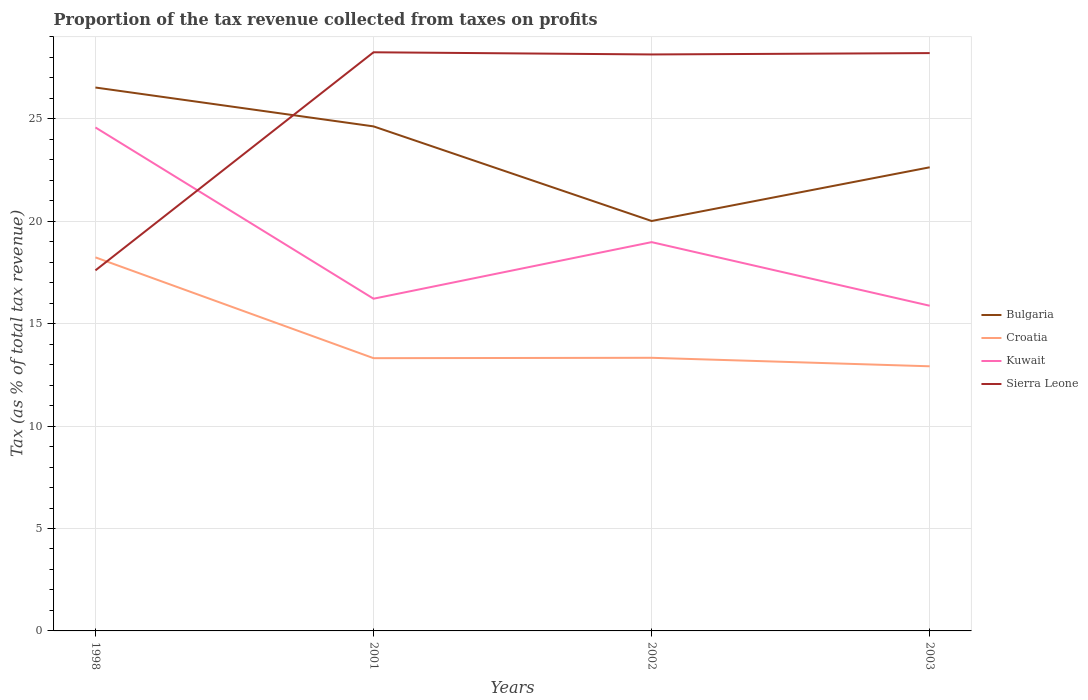How many different coloured lines are there?
Make the answer very short. 4. Is the number of lines equal to the number of legend labels?
Give a very brief answer. Yes. Across all years, what is the maximum proportion of the tax revenue collected in Bulgaria?
Your answer should be compact. 20.01. What is the total proportion of the tax revenue collected in Kuwait in the graph?
Your response must be concise. 0.34. What is the difference between the highest and the second highest proportion of the tax revenue collected in Sierra Leone?
Your response must be concise. 10.65. How many years are there in the graph?
Your answer should be compact. 4. Does the graph contain any zero values?
Give a very brief answer. No. Where does the legend appear in the graph?
Offer a very short reply. Center right. How are the legend labels stacked?
Give a very brief answer. Vertical. What is the title of the graph?
Offer a very short reply. Proportion of the tax revenue collected from taxes on profits. What is the label or title of the Y-axis?
Ensure brevity in your answer.  Tax (as % of total tax revenue). What is the Tax (as % of total tax revenue) of Bulgaria in 1998?
Give a very brief answer. 26.53. What is the Tax (as % of total tax revenue) of Croatia in 1998?
Keep it short and to the point. 18.23. What is the Tax (as % of total tax revenue) in Kuwait in 1998?
Your response must be concise. 24.58. What is the Tax (as % of total tax revenue) of Sierra Leone in 1998?
Offer a very short reply. 17.6. What is the Tax (as % of total tax revenue) in Bulgaria in 2001?
Keep it short and to the point. 24.63. What is the Tax (as % of total tax revenue) of Croatia in 2001?
Offer a very short reply. 13.31. What is the Tax (as % of total tax revenue) in Kuwait in 2001?
Provide a short and direct response. 16.22. What is the Tax (as % of total tax revenue) of Sierra Leone in 2001?
Make the answer very short. 28.25. What is the Tax (as % of total tax revenue) in Bulgaria in 2002?
Offer a terse response. 20.01. What is the Tax (as % of total tax revenue) in Croatia in 2002?
Provide a short and direct response. 13.33. What is the Tax (as % of total tax revenue) of Kuwait in 2002?
Provide a succinct answer. 18.98. What is the Tax (as % of total tax revenue) of Sierra Leone in 2002?
Provide a short and direct response. 28.14. What is the Tax (as % of total tax revenue) in Bulgaria in 2003?
Provide a short and direct response. 22.63. What is the Tax (as % of total tax revenue) in Croatia in 2003?
Offer a terse response. 12.92. What is the Tax (as % of total tax revenue) in Kuwait in 2003?
Offer a very short reply. 15.87. What is the Tax (as % of total tax revenue) of Sierra Leone in 2003?
Keep it short and to the point. 28.21. Across all years, what is the maximum Tax (as % of total tax revenue) of Bulgaria?
Keep it short and to the point. 26.53. Across all years, what is the maximum Tax (as % of total tax revenue) in Croatia?
Offer a terse response. 18.23. Across all years, what is the maximum Tax (as % of total tax revenue) of Kuwait?
Your answer should be very brief. 24.58. Across all years, what is the maximum Tax (as % of total tax revenue) in Sierra Leone?
Ensure brevity in your answer.  28.25. Across all years, what is the minimum Tax (as % of total tax revenue) in Bulgaria?
Offer a very short reply. 20.01. Across all years, what is the minimum Tax (as % of total tax revenue) in Croatia?
Ensure brevity in your answer.  12.92. Across all years, what is the minimum Tax (as % of total tax revenue) in Kuwait?
Offer a very short reply. 15.87. Across all years, what is the minimum Tax (as % of total tax revenue) of Sierra Leone?
Your response must be concise. 17.6. What is the total Tax (as % of total tax revenue) of Bulgaria in the graph?
Ensure brevity in your answer.  93.8. What is the total Tax (as % of total tax revenue) in Croatia in the graph?
Offer a terse response. 57.8. What is the total Tax (as % of total tax revenue) of Kuwait in the graph?
Your response must be concise. 75.64. What is the total Tax (as % of total tax revenue) in Sierra Leone in the graph?
Your answer should be very brief. 102.19. What is the difference between the Tax (as % of total tax revenue) of Bulgaria in 1998 and that in 2001?
Your answer should be very brief. 1.9. What is the difference between the Tax (as % of total tax revenue) of Croatia in 1998 and that in 2001?
Provide a short and direct response. 4.92. What is the difference between the Tax (as % of total tax revenue) of Kuwait in 1998 and that in 2001?
Your response must be concise. 8.36. What is the difference between the Tax (as % of total tax revenue) in Sierra Leone in 1998 and that in 2001?
Give a very brief answer. -10.65. What is the difference between the Tax (as % of total tax revenue) in Bulgaria in 1998 and that in 2002?
Your answer should be compact. 6.52. What is the difference between the Tax (as % of total tax revenue) in Croatia in 1998 and that in 2002?
Your response must be concise. 4.9. What is the difference between the Tax (as % of total tax revenue) in Kuwait in 1998 and that in 2002?
Provide a short and direct response. 5.6. What is the difference between the Tax (as % of total tax revenue) of Sierra Leone in 1998 and that in 2002?
Your answer should be very brief. -10.54. What is the difference between the Tax (as % of total tax revenue) of Bulgaria in 1998 and that in 2003?
Offer a terse response. 3.89. What is the difference between the Tax (as % of total tax revenue) in Croatia in 1998 and that in 2003?
Offer a terse response. 5.32. What is the difference between the Tax (as % of total tax revenue) of Kuwait in 1998 and that in 2003?
Your answer should be very brief. 8.7. What is the difference between the Tax (as % of total tax revenue) in Sierra Leone in 1998 and that in 2003?
Keep it short and to the point. -10.61. What is the difference between the Tax (as % of total tax revenue) in Bulgaria in 2001 and that in 2002?
Your response must be concise. 4.62. What is the difference between the Tax (as % of total tax revenue) of Croatia in 2001 and that in 2002?
Offer a terse response. -0.02. What is the difference between the Tax (as % of total tax revenue) in Kuwait in 2001 and that in 2002?
Offer a very short reply. -2.76. What is the difference between the Tax (as % of total tax revenue) in Sierra Leone in 2001 and that in 2002?
Provide a succinct answer. 0.11. What is the difference between the Tax (as % of total tax revenue) in Bulgaria in 2001 and that in 2003?
Your response must be concise. 2. What is the difference between the Tax (as % of total tax revenue) in Croatia in 2001 and that in 2003?
Your response must be concise. 0.4. What is the difference between the Tax (as % of total tax revenue) of Kuwait in 2001 and that in 2003?
Give a very brief answer. 0.34. What is the difference between the Tax (as % of total tax revenue) of Sierra Leone in 2001 and that in 2003?
Your answer should be compact. 0.04. What is the difference between the Tax (as % of total tax revenue) in Bulgaria in 2002 and that in 2003?
Your answer should be compact. -2.62. What is the difference between the Tax (as % of total tax revenue) in Croatia in 2002 and that in 2003?
Offer a terse response. 0.41. What is the difference between the Tax (as % of total tax revenue) in Kuwait in 2002 and that in 2003?
Provide a succinct answer. 3.11. What is the difference between the Tax (as % of total tax revenue) in Sierra Leone in 2002 and that in 2003?
Offer a terse response. -0.07. What is the difference between the Tax (as % of total tax revenue) of Bulgaria in 1998 and the Tax (as % of total tax revenue) of Croatia in 2001?
Offer a very short reply. 13.21. What is the difference between the Tax (as % of total tax revenue) in Bulgaria in 1998 and the Tax (as % of total tax revenue) in Kuwait in 2001?
Make the answer very short. 10.31. What is the difference between the Tax (as % of total tax revenue) in Bulgaria in 1998 and the Tax (as % of total tax revenue) in Sierra Leone in 2001?
Give a very brief answer. -1.72. What is the difference between the Tax (as % of total tax revenue) in Croatia in 1998 and the Tax (as % of total tax revenue) in Kuwait in 2001?
Provide a succinct answer. 2.02. What is the difference between the Tax (as % of total tax revenue) of Croatia in 1998 and the Tax (as % of total tax revenue) of Sierra Leone in 2001?
Your answer should be compact. -10.01. What is the difference between the Tax (as % of total tax revenue) in Kuwait in 1998 and the Tax (as % of total tax revenue) in Sierra Leone in 2001?
Provide a short and direct response. -3.67. What is the difference between the Tax (as % of total tax revenue) in Bulgaria in 1998 and the Tax (as % of total tax revenue) in Croatia in 2002?
Your answer should be very brief. 13.19. What is the difference between the Tax (as % of total tax revenue) of Bulgaria in 1998 and the Tax (as % of total tax revenue) of Kuwait in 2002?
Your answer should be compact. 7.55. What is the difference between the Tax (as % of total tax revenue) in Bulgaria in 1998 and the Tax (as % of total tax revenue) in Sierra Leone in 2002?
Provide a short and direct response. -1.61. What is the difference between the Tax (as % of total tax revenue) of Croatia in 1998 and the Tax (as % of total tax revenue) of Kuwait in 2002?
Ensure brevity in your answer.  -0.74. What is the difference between the Tax (as % of total tax revenue) in Croatia in 1998 and the Tax (as % of total tax revenue) in Sierra Leone in 2002?
Provide a short and direct response. -9.9. What is the difference between the Tax (as % of total tax revenue) of Kuwait in 1998 and the Tax (as % of total tax revenue) of Sierra Leone in 2002?
Provide a short and direct response. -3.56. What is the difference between the Tax (as % of total tax revenue) in Bulgaria in 1998 and the Tax (as % of total tax revenue) in Croatia in 2003?
Provide a short and direct response. 13.61. What is the difference between the Tax (as % of total tax revenue) of Bulgaria in 1998 and the Tax (as % of total tax revenue) of Kuwait in 2003?
Keep it short and to the point. 10.65. What is the difference between the Tax (as % of total tax revenue) in Bulgaria in 1998 and the Tax (as % of total tax revenue) in Sierra Leone in 2003?
Ensure brevity in your answer.  -1.68. What is the difference between the Tax (as % of total tax revenue) of Croatia in 1998 and the Tax (as % of total tax revenue) of Kuwait in 2003?
Your response must be concise. 2.36. What is the difference between the Tax (as % of total tax revenue) in Croatia in 1998 and the Tax (as % of total tax revenue) in Sierra Leone in 2003?
Keep it short and to the point. -9.97. What is the difference between the Tax (as % of total tax revenue) in Kuwait in 1998 and the Tax (as % of total tax revenue) in Sierra Leone in 2003?
Give a very brief answer. -3.63. What is the difference between the Tax (as % of total tax revenue) of Bulgaria in 2001 and the Tax (as % of total tax revenue) of Croatia in 2002?
Your answer should be compact. 11.3. What is the difference between the Tax (as % of total tax revenue) in Bulgaria in 2001 and the Tax (as % of total tax revenue) in Kuwait in 2002?
Your response must be concise. 5.65. What is the difference between the Tax (as % of total tax revenue) of Bulgaria in 2001 and the Tax (as % of total tax revenue) of Sierra Leone in 2002?
Give a very brief answer. -3.51. What is the difference between the Tax (as % of total tax revenue) in Croatia in 2001 and the Tax (as % of total tax revenue) in Kuwait in 2002?
Your response must be concise. -5.66. What is the difference between the Tax (as % of total tax revenue) in Croatia in 2001 and the Tax (as % of total tax revenue) in Sierra Leone in 2002?
Make the answer very short. -14.83. What is the difference between the Tax (as % of total tax revenue) in Kuwait in 2001 and the Tax (as % of total tax revenue) in Sierra Leone in 2002?
Keep it short and to the point. -11.92. What is the difference between the Tax (as % of total tax revenue) in Bulgaria in 2001 and the Tax (as % of total tax revenue) in Croatia in 2003?
Ensure brevity in your answer.  11.71. What is the difference between the Tax (as % of total tax revenue) in Bulgaria in 2001 and the Tax (as % of total tax revenue) in Kuwait in 2003?
Your answer should be very brief. 8.76. What is the difference between the Tax (as % of total tax revenue) in Bulgaria in 2001 and the Tax (as % of total tax revenue) in Sierra Leone in 2003?
Offer a terse response. -3.58. What is the difference between the Tax (as % of total tax revenue) of Croatia in 2001 and the Tax (as % of total tax revenue) of Kuwait in 2003?
Provide a short and direct response. -2.56. What is the difference between the Tax (as % of total tax revenue) of Croatia in 2001 and the Tax (as % of total tax revenue) of Sierra Leone in 2003?
Your answer should be very brief. -14.89. What is the difference between the Tax (as % of total tax revenue) of Kuwait in 2001 and the Tax (as % of total tax revenue) of Sierra Leone in 2003?
Provide a succinct answer. -11.99. What is the difference between the Tax (as % of total tax revenue) of Bulgaria in 2002 and the Tax (as % of total tax revenue) of Croatia in 2003?
Keep it short and to the point. 7.09. What is the difference between the Tax (as % of total tax revenue) of Bulgaria in 2002 and the Tax (as % of total tax revenue) of Kuwait in 2003?
Keep it short and to the point. 4.14. What is the difference between the Tax (as % of total tax revenue) in Bulgaria in 2002 and the Tax (as % of total tax revenue) in Sierra Leone in 2003?
Keep it short and to the point. -8.2. What is the difference between the Tax (as % of total tax revenue) in Croatia in 2002 and the Tax (as % of total tax revenue) in Kuwait in 2003?
Offer a very short reply. -2.54. What is the difference between the Tax (as % of total tax revenue) in Croatia in 2002 and the Tax (as % of total tax revenue) in Sierra Leone in 2003?
Offer a very short reply. -14.87. What is the difference between the Tax (as % of total tax revenue) in Kuwait in 2002 and the Tax (as % of total tax revenue) in Sierra Leone in 2003?
Your answer should be very brief. -9.23. What is the average Tax (as % of total tax revenue) of Bulgaria per year?
Your answer should be very brief. 23.45. What is the average Tax (as % of total tax revenue) of Croatia per year?
Offer a very short reply. 14.45. What is the average Tax (as % of total tax revenue) of Kuwait per year?
Make the answer very short. 18.91. What is the average Tax (as % of total tax revenue) in Sierra Leone per year?
Your response must be concise. 25.55. In the year 1998, what is the difference between the Tax (as % of total tax revenue) of Bulgaria and Tax (as % of total tax revenue) of Croatia?
Give a very brief answer. 8.29. In the year 1998, what is the difference between the Tax (as % of total tax revenue) of Bulgaria and Tax (as % of total tax revenue) of Kuwait?
Provide a succinct answer. 1.95. In the year 1998, what is the difference between the Tax (as % of total tax revenue) of Bulgaria and Tax (as % of total tax revenue) of Sierra Leone?
Ensure brevity in your answer.  8.93. In the year 1998, what is the difference between the Tax (as % of total tax revenue) of Croatia and Tax (as % of total tax revenue) of Kuwait?
Your answer should be compact. -6.34. In the year 1998, what is the difference between the Tax (as % of total tax revenue) of Croatia and Tax (as % of total tax revenue) of Sierra Leone?
Your response must be concise. 0.64. In the year 1998, what is the difference between the Tax (as % of total tax revenue) in Kuwait and Tax (as % of total tax revenue) in Sierra Leone?
Provide a succinct answer. 6.98. In the year 2001, what is the difference between the Tax (as % of total tax revenue) in Bulgaria and Tax (as % of total tax revenue) in Croatia?
Your answer should be very brief. 11.31. In the year 2001, what is the difference between the Tax (as % of total tax revenue) of Bulgaria and Tax (as % of total tax revenue) of Kuwait?
Give a very brief answer. 8.41. In the year 2001, what is the difference between the Tax (as % of total tax revenue) in Bulgaria and Tax (as % of total tax revenue) in Sierra Leone?
Ensure brevity in your answer.  -3.62. In the year 2001, what is the difference between the Tax (as % of total tax revenue) in Croatia and Tax (as % of total tax revenue) in Kuwait?
Make the answer very short. -2.9. In the year 2001, what is the difference between the Tax (as % of total tax revenue) of Croatia and Tax (as % of total tax revenue) of Sierra Leone?
Ensure brevity in your answer.  -14.93. In the year 2001, what is the difference between the Tax (as % of total tax revenue) of Kuwait and Tax (as % of total tax revenue) of Sierra Leone?
Your answer should be compact. -12.03. In the year 2002, what is the difference between the Tax (as % of total tax revenue) of Bulgaria and Tax (as % of total tax revenue) of Croatia?
Provide a succinct answer. 6.68. In the year 2002, what is the difference between the Tax (as % of total tax revenue) in Bulgaria and Tax (as % of total tax revenue) in Kuwait?
Make the answer very short. 1.03. In the year 2002, what is the difference between the Tax (as % of total tax revenue) in Bulgaria and Tax (as % of total tax revenue) in Sierra Leone?
Ensure brevity in your answer.  -8.13. In the year 2002, what is the difference between the Tax (as % of total tax revenue) of Croatia and Tax (as % of total tax revenue) of Kuwait?
Offer a terse response. -5.65. In the year 2002, what is the difference between the Tax (as % of total tax revenue) in Croatia and Tax (as % of total tax revenue) in Sierra Leone?
Offer a very short reply. -14.81. In the year 2002, what is the difference between the Tax (as % of total tax revenue) of Kuwait and Tax (as % of total tax revenue) of Sierra Leone?
Keep it short and to the point. -9.16. In the year 2003, what is the difference between the Tax (as % of total tax revenue) in Bulgaria and Tax (as % of total tax revenue) in Croatia?
Offer a terse response. 9.71. In the year 2003, what is the difference between the Tax (as % of total tax revenue) of Bulgaria and Tax (as % of total tax revenue) of Kuwait?
Make the answer very short. 6.76. In the year 2003, what is the difference between the Tax (as % of total tax revenue) in Bulgaria and Tax (as % of total tax revenue) in Sierra Leone?
Provide a succinct answer. -5.57. In the year 2003, what is the difference between the Tax (as % of total tax revenue) of Croatia and Tax (as % of total tax revenue) of Kuwait?
Provide a succinct answer. -2.96. In the year 2003, what is the difference between the Tax (as % of total tax revenue) of Croatia and Tax (as % of total tax revenue) of Sierra Leone?
Provide a succinct answer. -15.29. In the year 2003, what is the difference between the Tax (as % of total tax revenue) of Kuwait and Tax (as % of total tax revenue) of Sierra Leone?
Your answer should be compact. -12.33. What is the ratio of the Tax (as % of total tax revenue) in Bulgaria in 1998 to that in 2001?
Your answer should be compact. 1.08. What is the ratio of the Tax (as % of total tax revenue) in Croatia in 1998 to that in 2001?
Ensure brevity in your answer.  1.37. What is the ratio of the Tax (as % of total tax revenue) in Kuwait in 1998 to that in 2001?
Ensure brevity in your answer.  1.52. What is the ratio of the Tax (as % of total tax revenue) in Sierra Leone in 1998 to that in 2001?
Your answer should be compact. 0.62. What is the ratio of the Tax (as % of total tax revenue) in Bulgaria in 1998 to that in 2002?
Give a very brief answer. 1.33. What is the ratio of the Tax (as % of total tax revenue) in Croatia in 1998 to that in 2002?
Provide a succinct answer. 1.37. What is the ratio of the Tax (as % of total tax revenue) of Kuwait in 1998 to that in 2002?
Offer a terse response. 1.29. What is the ratio of the Tax (as % of total tax revenue) of Sierra Leone in 1998 to that in 2002?
Your answer should be compact. 0.63. What is the ratio of the Tax (as % of total tax revenue) in Bulgaria in 1998 to that in 2003?
Make the answer very short. 1.17. What is the ratio of the Tax (as % of total tax revenue) in Croatia in 1998 to that in 2003?
Your answer should be very brief. 1.41. What is the ratio of the Tax (as % of total tax revenue) of Kuwait in 1998 to that in 2003?
Your response must be concise. 1.55. What is the ratio of the Tax (as % of total tax revenue) in Sierra Leone in 1998 to that in 2003?
Provide a succinct answer. 0.62. What is the ratio of the Tax (as % of total tax revenue) in Bulgaria in 2001 to that in 2002?
Provide a short and direct response. 1.23. What is the ratio of the Tax (as % of total tax revenue) of Kuwait in 2001 to that in 2002?
Your answer should be very brief. 0.85. What is the ratio of the Tax (as % of total tax revenue) of Bulgaria in 2001 to that in 2003?
Your answer should be very brief. 1.09. What is the ratio of the Tax (as % of total tax revenue) of Croatia in 2001 to that in 2003?
Your answer should be very brief. 1.03. What is the ratio of the Tax (as % of total tax revenue) of Kuwait in 2001 to that in 2003?
Provide a succinct answer. 1.02. What is the ratio of the Tax (as % of total tax revenue) of Bulgaria in 2002 to that in 2003?
Make the answer very short. 0.88. What is the ratio of the Tax (as % of total tax revenue) in Croatia in 2002 to that in 2003?
Ensure brevity in your answer.  1.03. What is the ratio of the Tax (as % of total tax revenue) in Kuwait in 2002 to that in 2003?
Keep it short and to the point. 1.2. What is the ratio of the Tax (as % of total tax revenue) of Sierra Leone in 2002 to that in 2003?
Provide a short and direct response. 1. What is the difference between the highest and the second highest Tax (as % of total tax revenue) in Bulgaria?
Give a very brief answer. 1.9. What is the difference between the highest and the second highest Tax (as % of total tax revenue) of Croatia?
Your answer should be compact. 4.9. What is the difference between the highest and the second highest Tax (as % of total tax revenue) of Kuwait?
Your answer should be compact. 5.6. What is the difference between the highest and the second highest Tax (as % of total tax revenue) in Sierra Leone?
Provide a short and direct response. 0.04. What is the difference between the highest and the lowest Tax (as % of total tax revenue) of Bulgaria?
Your answer should be compact. 6.52. What is the difference between the highest and the lowest Tax (as % of total tax revenue) of Croatia?
Keep it short and to the point. 5.32. What is the difference between the highest and the lowest Tax (as % of total tax revenue) of Kuwait?
Provide a short and direct response. 8.7. What is the difference between the highest and the lowest Tax (as % of total tax revenue) of Sierra Leone?
Your answer should be very brief. 10.65. 